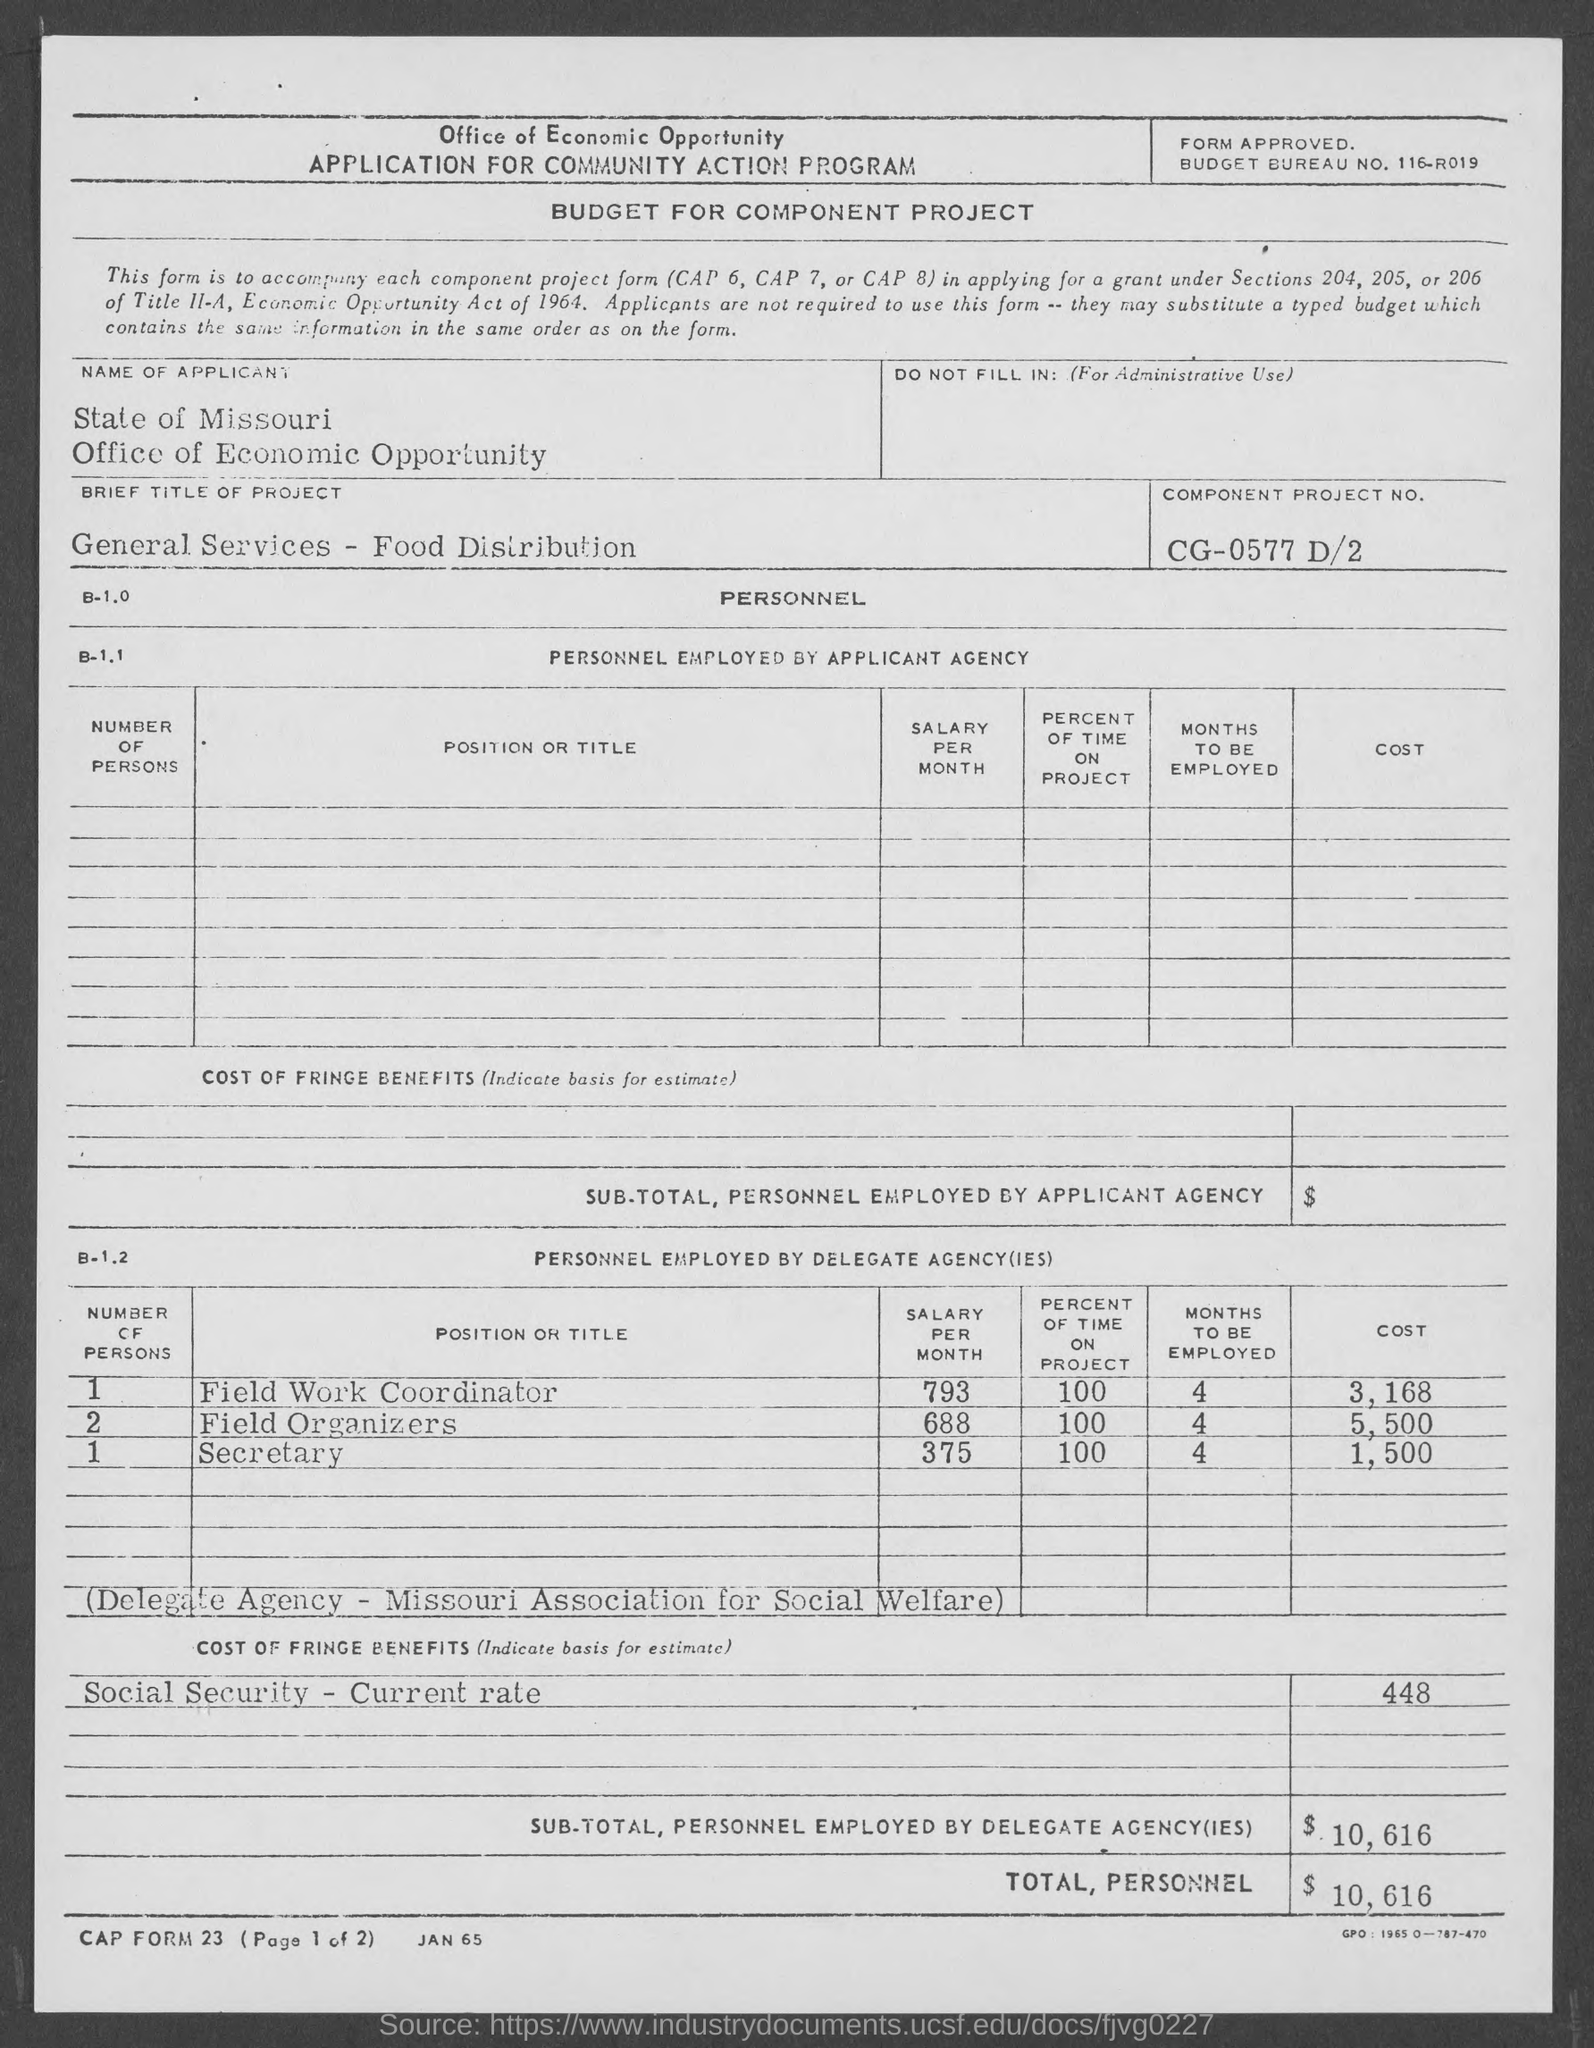What is the budget bureau no.?
Your response must be concise. 116-R019. What is the brief  title of project?
Provide a short and direct response. General Services - Food Distribution. What is component project no.?
Give a very brief answer. Cg-0577 d/2. What is the total, personnel cost?
Offer a terse response. $10,616. 